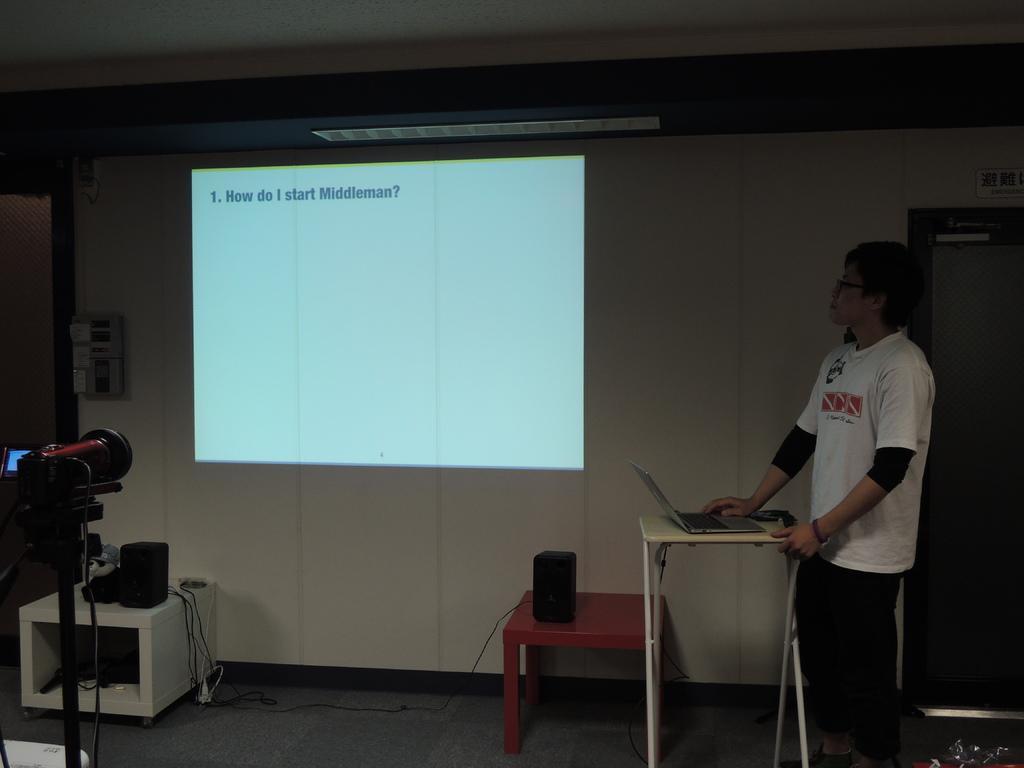Describe this image in one or two sentences. On the right side there is a man who is wearing a white t-shirt, standing beside the table. He is seeing on the projector. He is working on a laptop. On the table there is a speakers. On left side there is a camera which is shooting the projector. On the side there is a door. Here it's a switches board. 